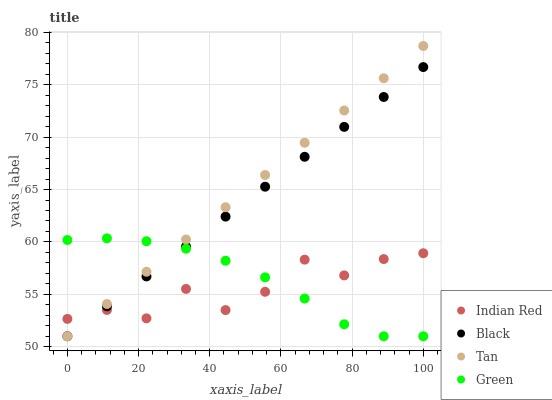Does Indian Red have the minimum area under the curve?
Answer yes or no. Yes. Does Tan have the maximum area under the curve?
Answer yes or no. Yes. Does Black have the minimum area under the curve?
Answer yes or no. No. Does Black have the maximum area under the curve?
Answer yes or no. No. Is Black the smoothest?
Answer yes or no. Yes. Is Indian Red the roughest?
Answer yes or no. Yes. Is Tan the smoothest?
Answer yes or no. No. Is Tan the roughest?
Answer yes or no. No. Does Green have the lowest value?
Answer yes or no. Yes. Does Indian Red have the lowest value?
Answer yes or no. No. Does Tan have the highest value?
Answer yes or no. Yes. Does Black have the highest value?
Answer yes or no. No. Does Green intersect Tan?
Answer yes or no. Yes. Is Green less than Tan?
Answer yes or no. No. Is Green greater than Tan?
Answer yes or no. No. 